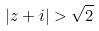<formula> <loc_0><loc_0><loc_500><loc_500>| z + i | > \sqrt { 2 }</formula> 